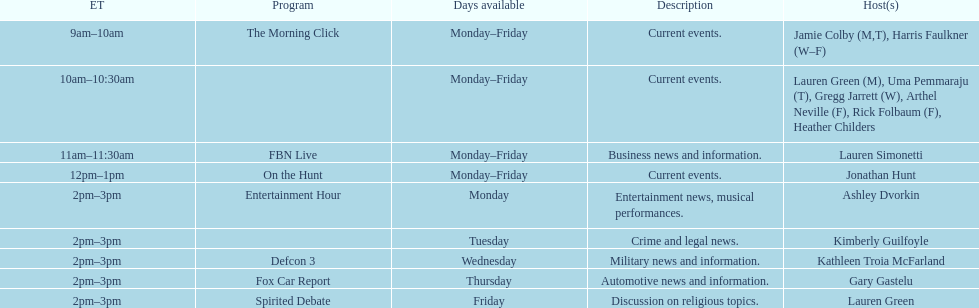Tell me the number of shows that only have one host per day. 7. 